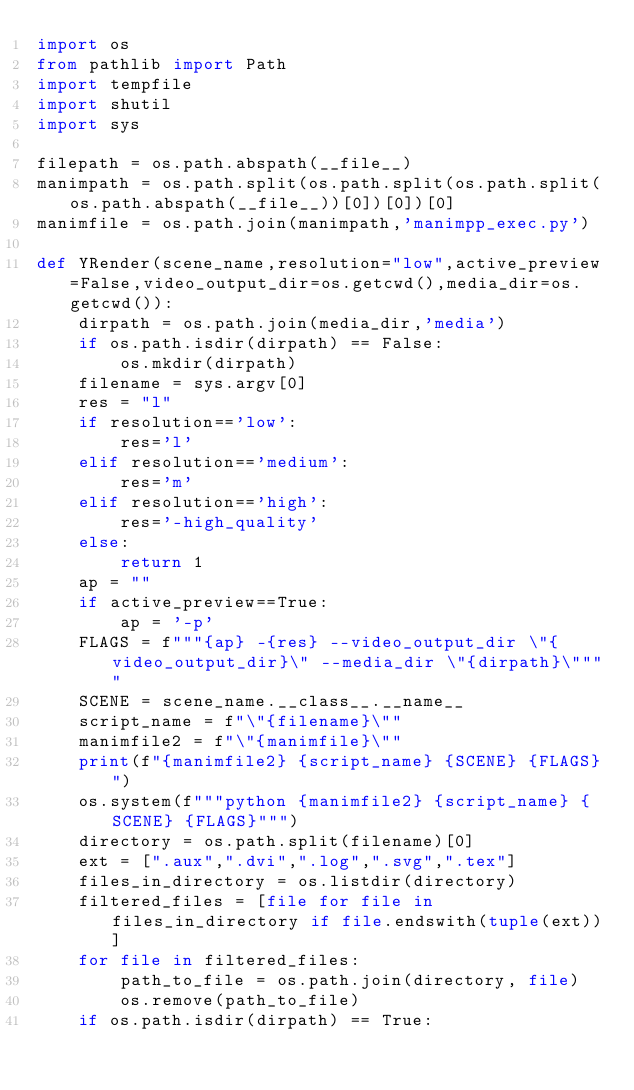<code> <loc_0><loc_0><loc_500><loc_500><_Python_>import os
from pathlib import Path
import tempfile
import shutil
import sys

filepath = os.path.abspath(__file__)
manimpath = os.path.split(os.path.split(os.path.split(os.path.abspath(__file__))[0])[0])[0]
manimfile = os.path.join(manimpath,'manimpp_exec.py')

def YRender(scene_name,resolution="low",active_preview=False,video_output_dir=os.getcwd(),media_dir=os.getcwd()):
    dirpath = os.path.join(media_dir,'media')
    if os.path.isdir(dirpath) == False:
        os.mkdir(dirpath)
    filename = sys.argv[0]
    res = "l"
    if resolution=='low':
        res='l'
    elif resolution=='medium':
        res='m'
    elif resolution=='high':
        res='-high_quality'
    else:
        return 1
    ap = ""
    if active_preview==True:
        ap = '-p'
    FLAGS = f"""{ap} -{res} --video_output_dir \"{video_output_dir}\" --media_dir \"{dirpath}\""""
    SCENE = scene_name.__class__.__name__
    script_name = f"\"{filename}\""
    manimfile2 = f"\"{manimfile}\""
    print(f"{manimfile2} {script_name} {SCENE} {FLAGS}")
    os.system(f"""python {manimfile2} {script_name} {SCENE} {FLAGS}""")
    directory = os.path.split(filename)[0]
    ext = [".aux",".dvi",".log",".svg",".tex"]
    files_in_directory = os.listdir(directory)
    filtered_files = [file for file in files_in_directory if file.endswith(tuple(ext))]
    for file in filtered_files:
        path_to_file = os.path.join(directory, file)
        os.remove(path_to_file)
    if os.path.isdir(dirpath) == True:</code> 